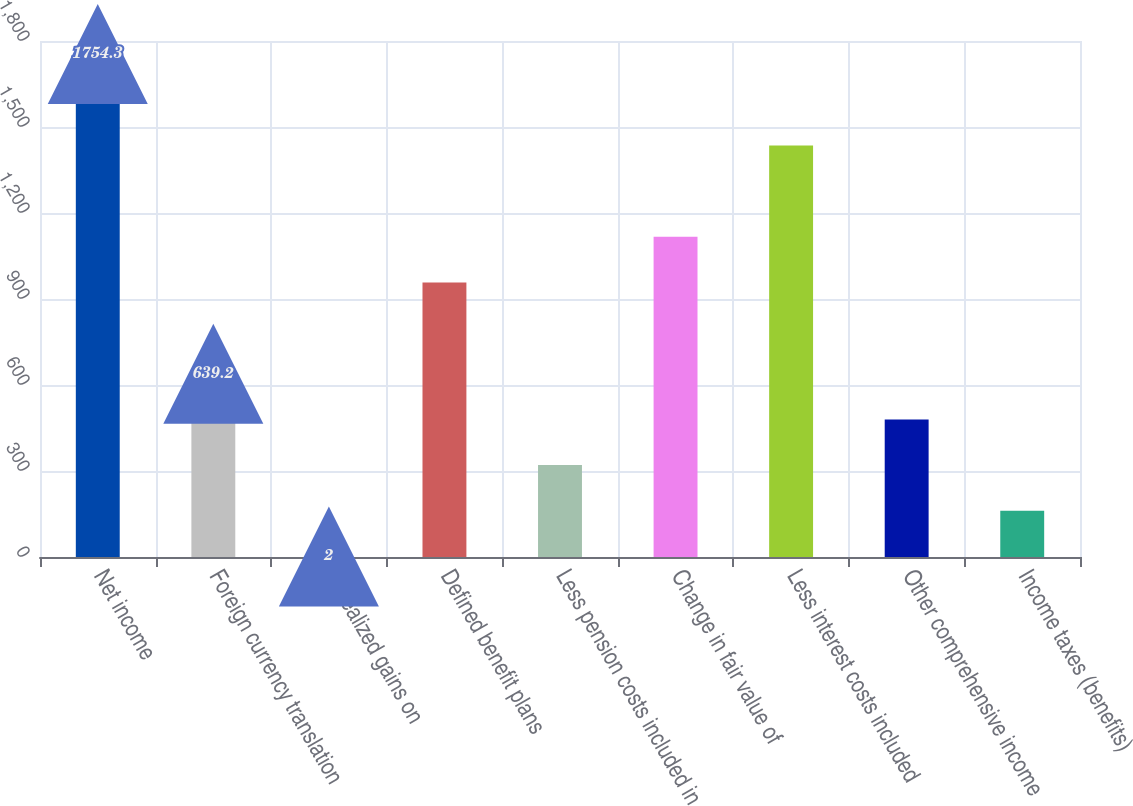Convert chart to OTSL. <chart><loc_0><loc_0><loc_500><loc_500><bar_chart><fcel>Net income<fcel>Foreign currency translation<fcel>Unrealized gains on<fcel>Defined benefit plans<fcel>Less pension costs included in<fcel>Change in fair value of<fcel>Less interest costs included<fcel>Other comprehensive income<fcel>Income taxes (benefits)<nl><fcel>1754.3<fcel>639.2<fcel>2<fcel>957.8<fcel>320.6<fcel>1117.1<fcel>1435.7<fcel>479.9<fcel>161.3<nl></chart> 